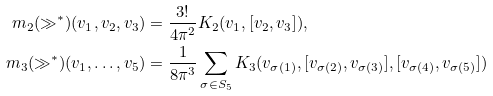<formula> <loc_0><loc_0><loc_500><loc_500>m _ { 2 } ( \gg ^ { * } ) ( v _ { 1 } , v _ { 2 } , v _ { 3 } ) & = \frac { 3 ! } { 4 \pi ^ { 2 } } K _ { 2 } ( v _ { 1 } , [ v _ { 2 } , v _ { 3 } ] ) , \\ m _ { 3 } ( \gg ^ { * } ) ( v _ { 1 } , \dots , v _ { 5 } ) & = \frac { 1 } { 8 \pi ^ { 3 } } \sum _ { \sigma \in S _ { 5 } } K _ { 3 } ( v _ { \sigma ( 1 ) } , [ v _ { \sigma ( 2 ) } , v _ { \sigma ( 3 ) } ] , [ v _ { \sigma ( 4 ) } , v _ { \sigma ( 5 ) } ] )</formula> 